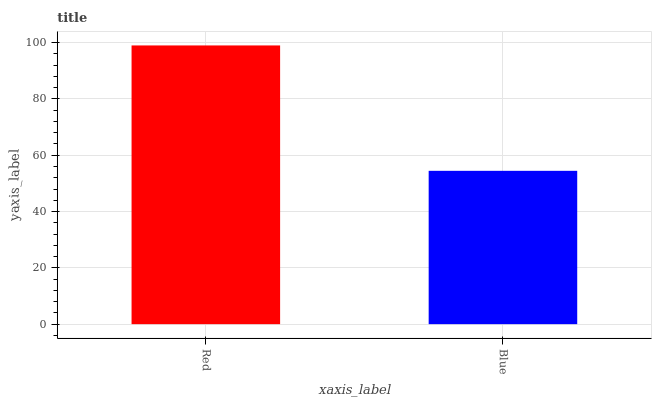Is Blue the minimum?
Answer yes or no. Yes. Is Red the maximum?
Answer yes or no. Yes. Is Blue the maximum?
Answer yes or no. No. Is Red greater than Blue?
Answer yes or no. Yes. Is Blue less than Red?
Answer yes or no. Yes. Is Blue greater than Red?
Answer yes or no. No. Is Red less than Blue?
Answer yes or no. No. Is Red the high median?
Answer yes or no. Yes. Is Blue the low median?
Answer yes or no. Yes. Is Blue the high median?
Answer yes or no. No. Is Red the low median?
Answer yes or no. No. 